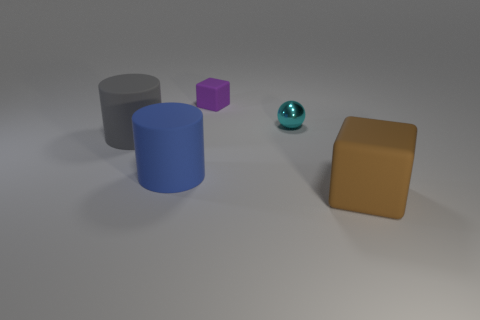Are there any other things that are the same shape as the shiny object?
Your answer should be compact. No. There is a rubber thing behind the gray cylinder; what is its shape?
Your answer should be compact. Cube. What number of other things are made of the same material as the tiny ball?
Give a very brief answer. 0. What material is the big brown thing?
Your answer should be compact. Rubber. How many small objects are metallic balls or rubber objects?
Your response must be concise. 2. There is a purple block; how many small purple rubber blocks are behind it?
Your answer should be compact. 0. What shape is the gray rubber thing that is the same size as the blue rubber object?
Provide a succinct answer. Cylinder. How many cyan things are cylinders or matte blocks?
Offer a very short reply. 0. How many cyan shiny balls have the same size as the brown rubber cube?
Give a very brief answer. 0. How many objects are either brown rubber blocks or rubber things that are on the right side of the shiny thing?
Keep it short and to the point. 1. 